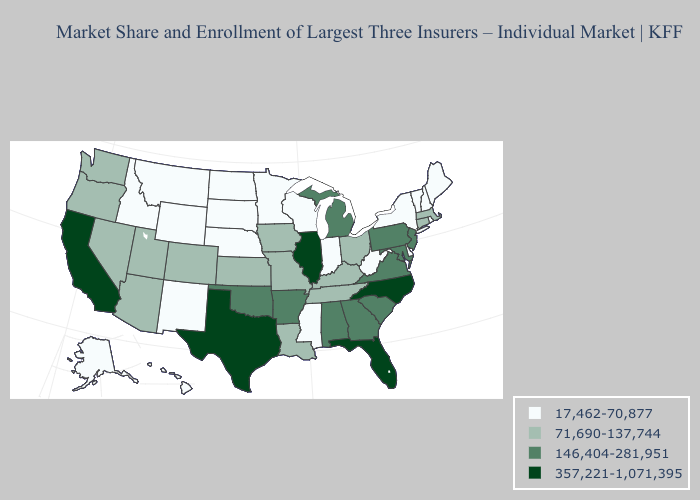Is the legend a continuous bar?
Quick response, please. No. Name the states that have a value in the range 146,404-281,951?
Quick response, please. Alabama, Arkansas, Georgia, Maryland, Michigan, New Jersey, Oklahoma, Pennsylvania, South Carolina, Virginia. Name the states that have a value in the range 146,404-281,951?
Be succinct. Alabama, Arkansas, Georgia, Maryland, Michigan, New Jersey, Oklahoma, Pennsylvania, South Carolina, Virginia. What is the lowest value in the USA?
Keep it brief. 17,462-70,877. What is the lowest value in the West?
Keep it brief. 17,462-70,877. Does the first symbol in the legend represent the smallest category?
Short answer required. Yes. What is the lowest value in states that border West Virginia?
Answer briefly. 71,690-137,744. What is the value of Missouri?
Be succinct. 71,690-137,744. What is the highest value in states that border Iowa?
Quick response, please. 357,221-1,071,395. What is the highest value in the Northeast ?
Answer briefly. 146,404-281,951. Does North Dakota have the lowest value in the MidWest?
Give a very brief answer. Yes. What is the lowest value in the USA?
Keep it brief. 17,462-70,877. Name the states that have a value in the range 146,404-281,951?
Concise answer only. Alabama, Arkansas, Georgia, Maryland, Michigan, New Jersey, Oklahoma, Pennsylvania, South Carolina, Virginia. Is the legend a continuous bar?
Keep it brief. No. What is the highest value in states that border Maine?
Write a very short answer. 17,462-70,877. 